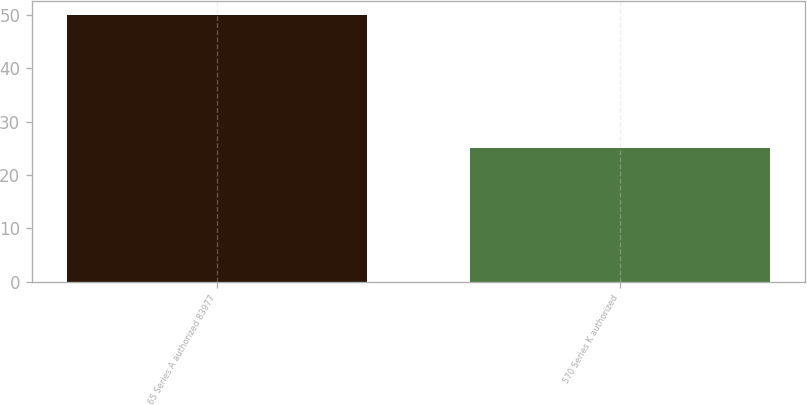Convert chart. <chart><loc_0><loc_0><loc_500><loc_500><bar_chart><fcel>65 Series A authorized 83977<fcel>570 Series K authorized<nl><fcel>50<fcel>25<nl></chart> 